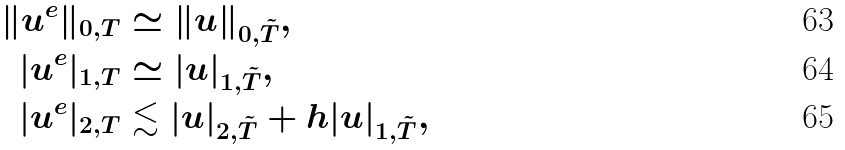<formula> <loc_0><loc_0><loc_500><loc_500>\| u ^ { e } \| _ { 0 , T } & \simeq \| u \| _ { 0 , \tilde { T } } , \\ | u ^ { e } | _ { 1 , T } & \simeq | u | _ { 1 , \tilde { T } } , \\ | u ^ { e } | _ { 2 , T } & \lesssim | u | _ { 2 , \tilde { T } } + h | u | _ { 1 , \tilde { T } } ,</formula> 